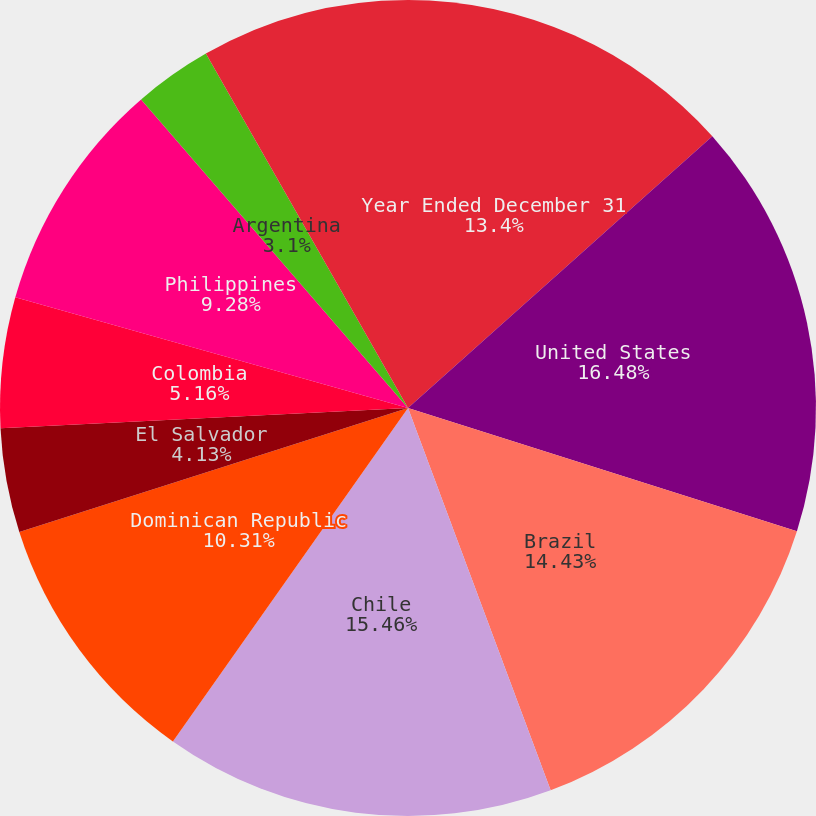Convert chart. <chart><loc_0><loc_0><loc_500><loc_500><pie_chart><fcel>Year Ended December 31<fcel>United States<fcel>Brazil<fcel>Chile<fcel>Dominican Republic<fcel>El Salvador<fcel>Colombia<fcel>Philippines<fcel>Argentina<fcel>Mexico<nl><fcel>13.4%<fcel>16.49%<fcel>14.43%<fcel>15.46%<fcel>10.31%<fcel>4.13%<fcel>5.16%<fcel>9.28%<fcel>3.1%<fcel>8.25%<nl></chart> 